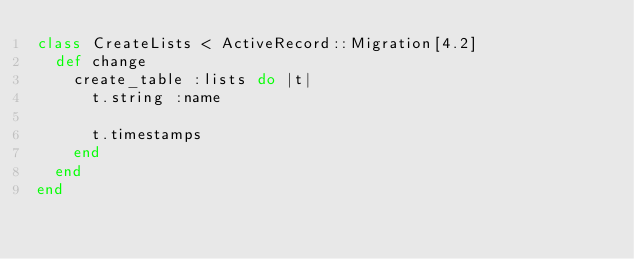Convert code to text. <code><loc_0><loc_0><loc_500><loc_500><_Ruby_>class CreateLists < ActiveRecord::Migration[4.2]
  def change
    create_table :lists do |t|
      t.string :name

      t.timestamps
    end
  end
end
</code> 